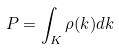<formula> <loc_0><loc_0><loc_500><loc_500>P = \int _ { K } \rho ( k ) d k</formula> 